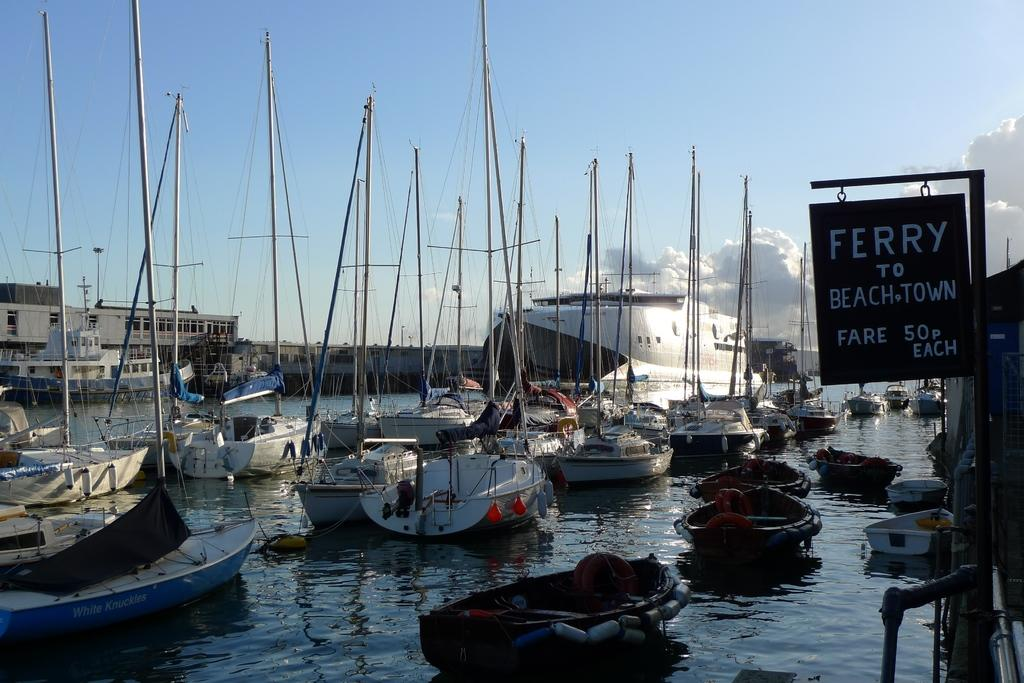<image>
Give a short and clear explanation of the subsequent image. Boats docked by a sign which says "Ferry" on it. 